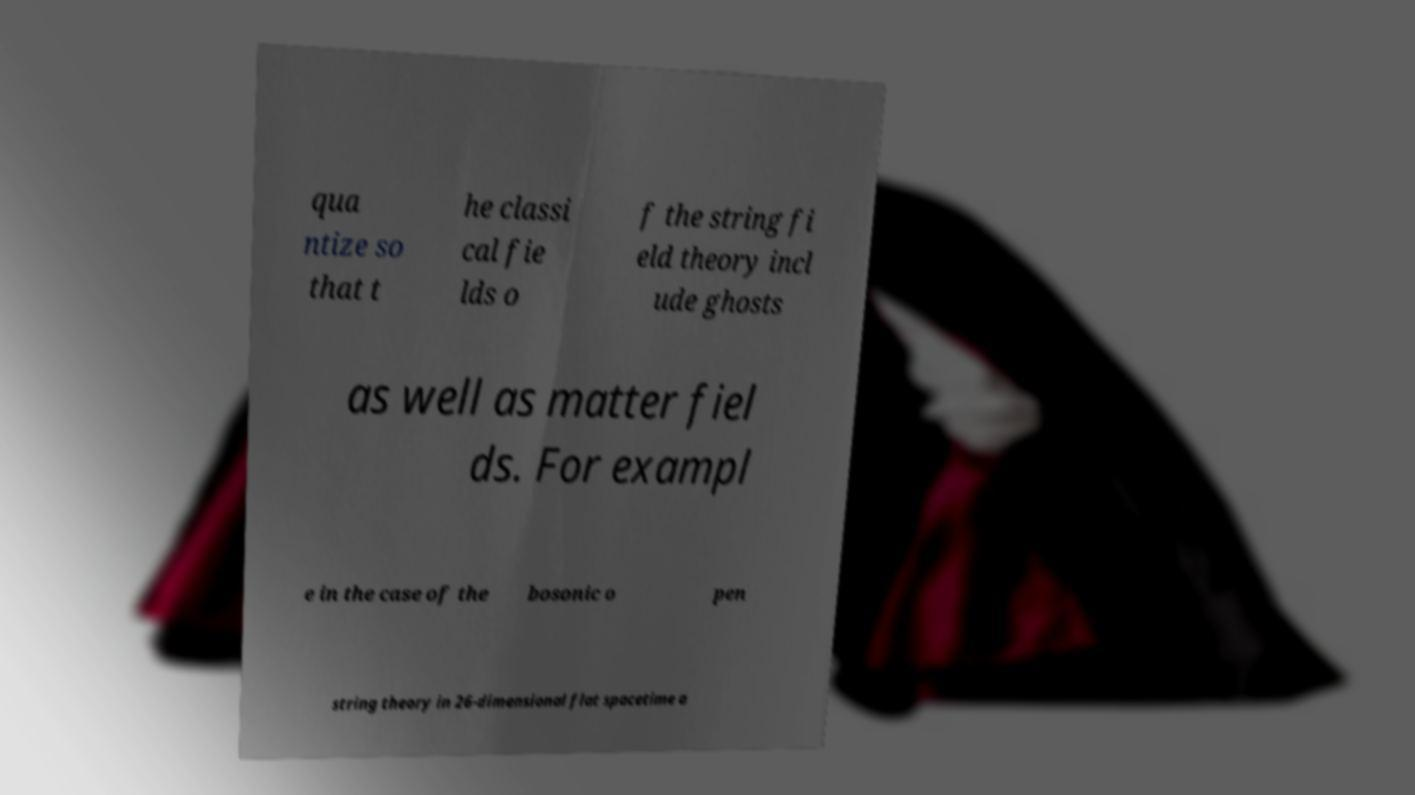Please identify and transcribe the text found in this image. qua ntize so that t he classi cal fie lds o f the string fi eld theory incl ude ghosts as well as matter fiel ds. For exampl e in the case of the bosonic o pen string theory in 26-dimensional flat spacetime a 